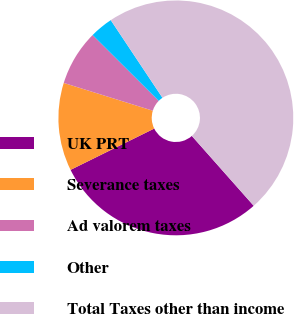Convert chart. <chart><loc_0><loc_0><loc_500><loc_500><pie_chart><fcel>UK PRT<fcel>Severance taxes<fcel>Ad valorem taxes<fcel>Other<fcel>Total Taxes other than income<nl><fcel>29.24%<fcel>12.11%<fcel>7.65%<fcel>3.19%<fcel>47.81%<nl></chart> 